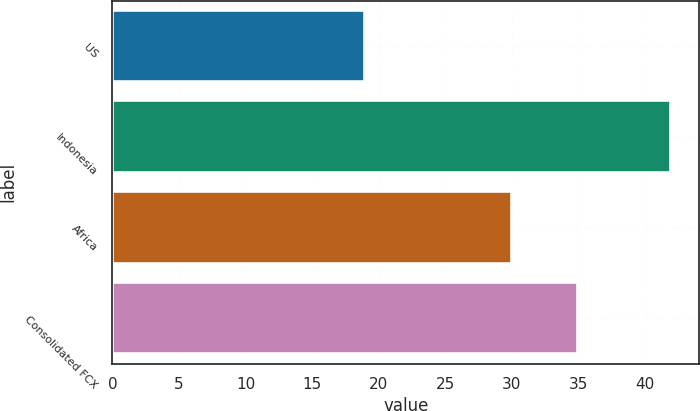Convert chart. <chart><loc_0><loc_0><loc_500><loc_500><bar_chart><fcel>US<fcel>Indonesia<fcel>Africa<fcel>Consolidated FCX<nl><fcel>19<fcel>42<fcel>30<fcel>35<nl></chart> 